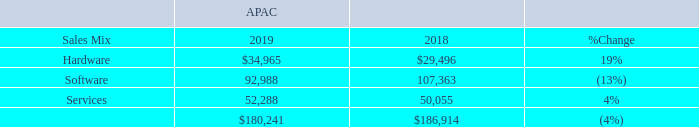Our net sales by offering category for APAC for 2019 and 2018, were as follows (dollars in thousands):
Net sales in APAC decreased 4% (increased 2% excluding the effects of fluctuating foreign currency rates), or $6.7 million, in 2019 compared to 2018. In APAC, increases in hardware and services net sales year over year were offset by a decrease in software net sales during 2019 compared to 2018. The changes were the result of the following:
• Continued expansion of hardware offerings in the APAC market resulted in higher net sales in this category.
• Continued trend toward higher sales of cloud solution offerings that are recorded on a net sales recognition basis in the services net sales category resulted in declines in the software net sales category.
• Higher volume of net sales of cloud solution offerings and software referral fees that are recorded on a net sales recognition basis positively impacted services net sales. Additionally, there were contributions from Insight delivered services from increased net sales of our digital innovation solutions offering.
What is the net sales of hardware in 2019 and 2018 respectively?
Answer scale should be: thousand. $34,965, $29,496. What is the net sales of software in 2019 and 2018 respectively?
Answer scale should be: thousand. 92,988, 107,363. How much did net sales in decreased in 2019 compared to 2018? $6.7 million. What is the change in Sales Mix of Hardware between 2018 and 2019?
Answer scale should be: thousand. 34,965-29,496
Answer: 5469. What is the change in Sales Mix of Software between 2018 and 2019?
Answer scale should be: thousand. 92,988-107,363
Answer: -14375. What is the average Sales Mix of Hardware for 2018 and 2019?
Answer scale should be: thousand. (34,965+29,496) / 2
Answer: 32230.5. 